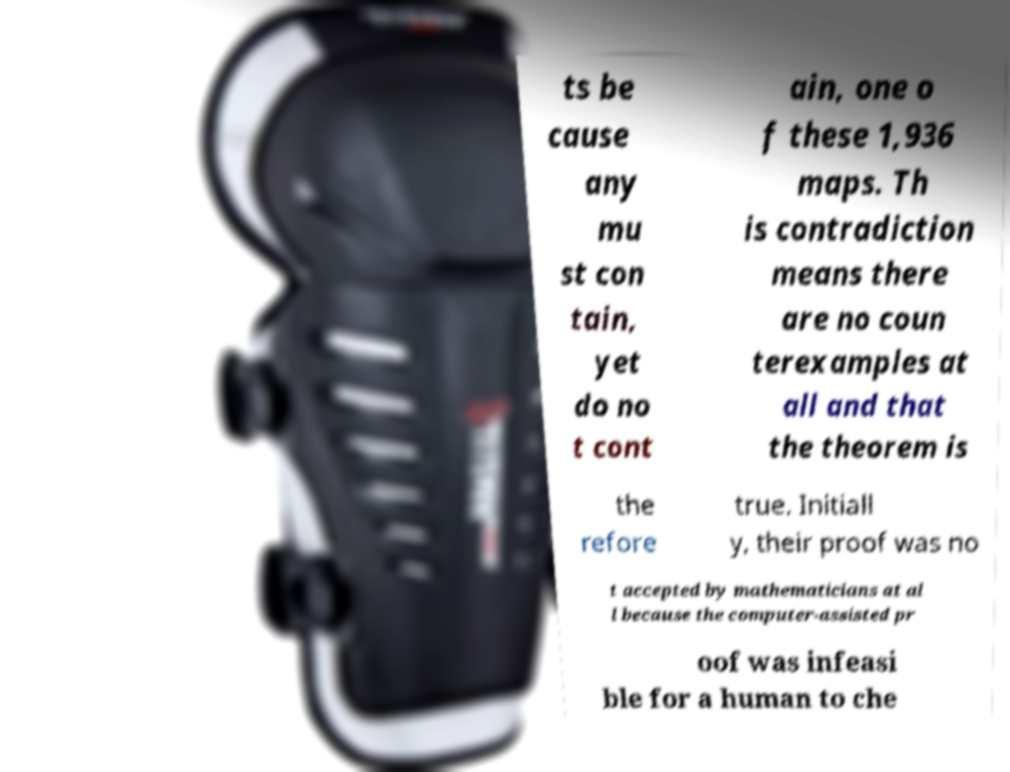Please read and relay the text visible in this image. What does it say? ts be cause any mu st con tain, yet do no t cont ain, one o f these 1,936 maps. Th is contradiction means there are no coun terexamples at all and that the theorem is the refore true. Initiall y, their proof was no t accepted by mathematicians at al l because the computer-assisted pr oof was infeasi ble for a human to che 